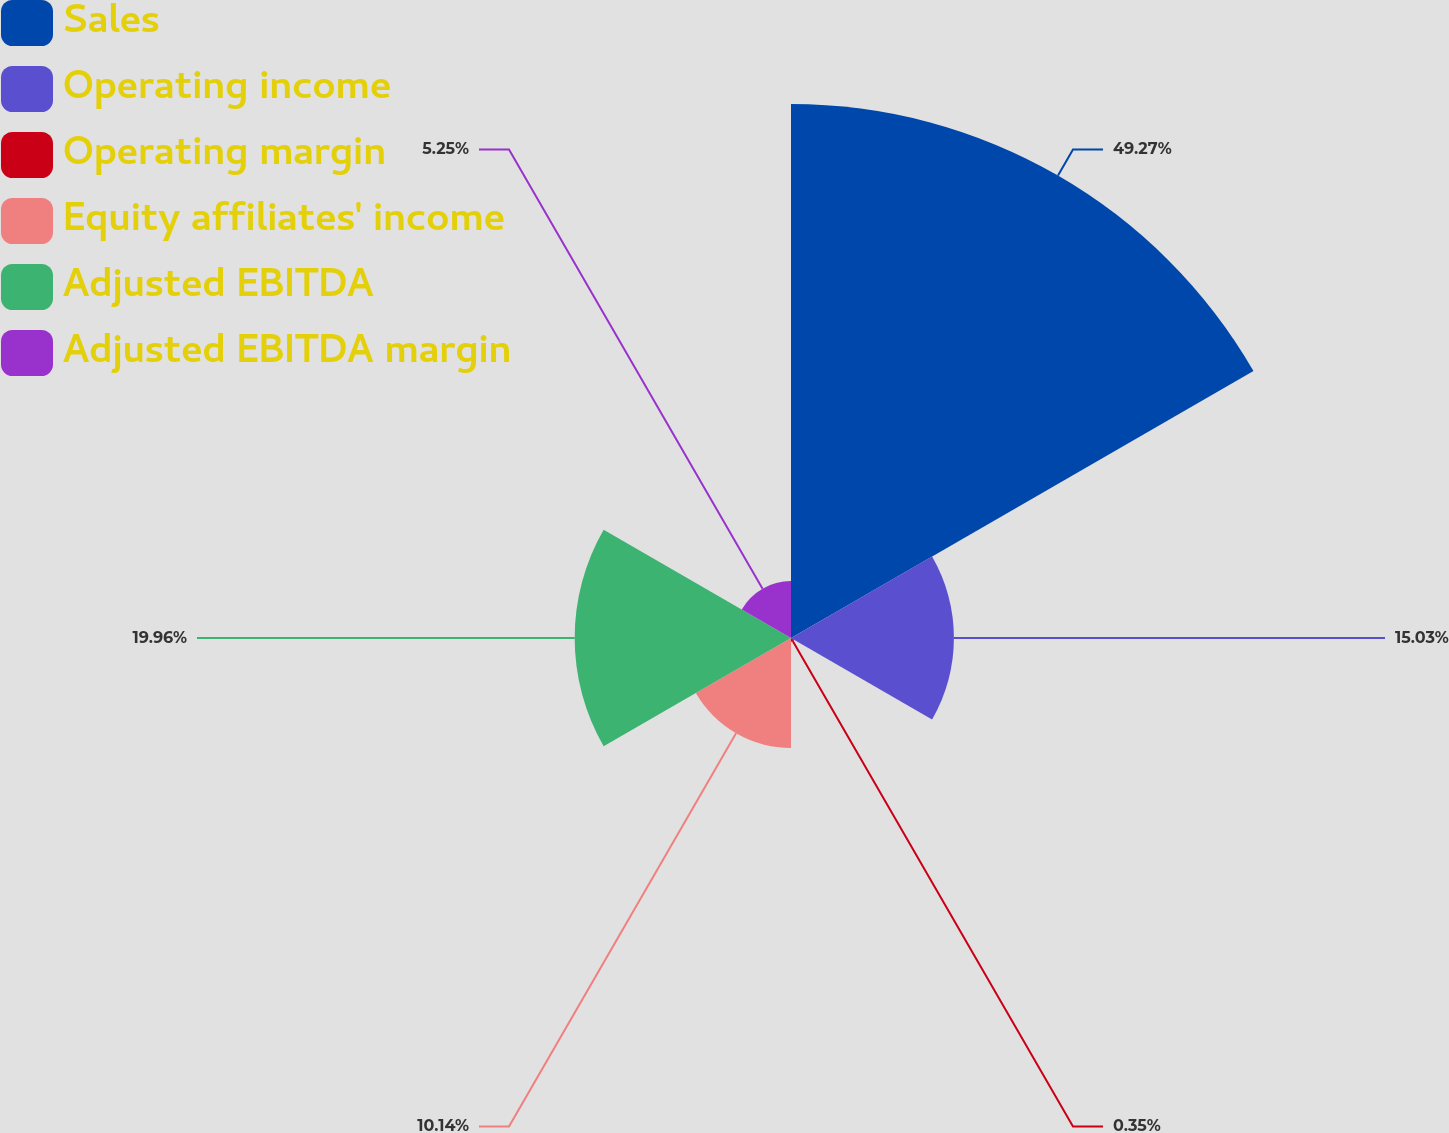Convert chart to OTSL. <chart><loc_0><loc_0><loc_500><loc_500><pie_chart><fcel>Sales<fcel>Operating income<fcel>Operating margin<fcel>Equity affiliates' income<fcel>Adjusted EBITDA<fcel>Adjusted EBITDA margin<nl><fcel>49.27%<fcel>15.03%<fcel>0.35%<fcel>10.14%<fcel>19.96%<fcel>5.25%<nl></chart> 